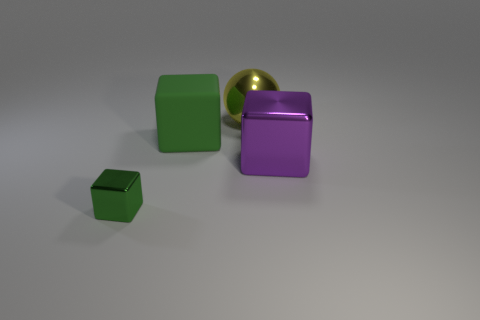What kind of mood or theme could this image represent? The image could be interpreted as evoking a sense of order and minimalism. The clean lines, the clear distinction between the shapes and colors of the objects, and the soft lighting might suggest themes of clarity, simplicity, and the beauty found in the basics of geometry and color theory. 